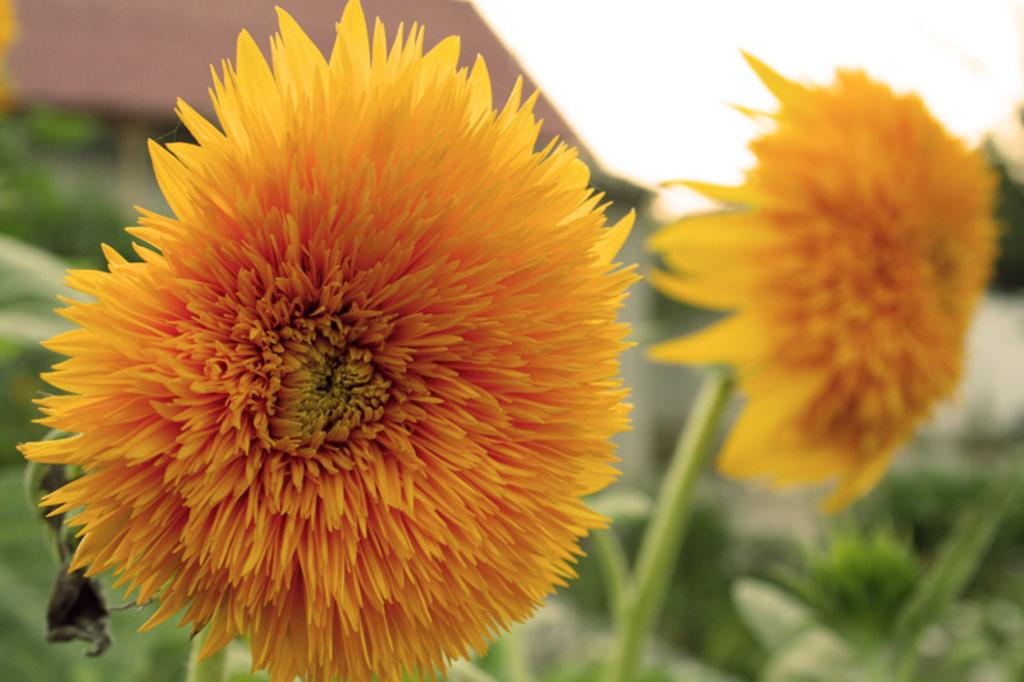What type of living organisms can be seen in the image? Plants and flowers are visible in the image. Can you describe the sky in the image? The sky is visible at the top of the image. What type of bell can be seen hanging from the flowers in the image? There is no bell present in the image; it features plants and flowers. How many chickens are visible in the image? There are no chickens present in the image. 